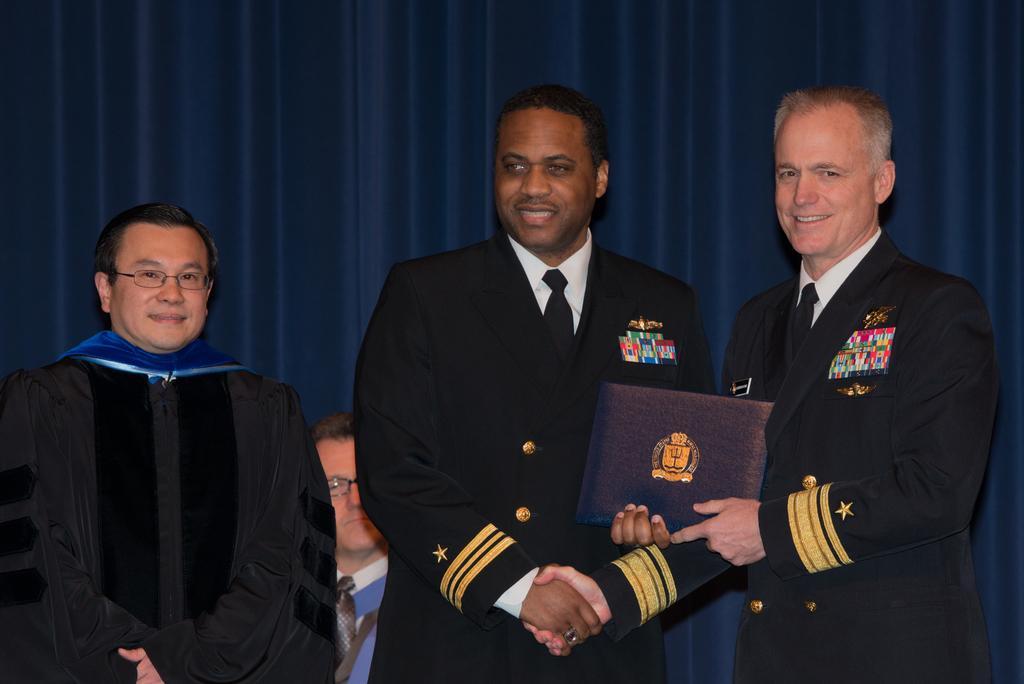Can you describe this image briefly? In this image we can see three persons standing. In the back there is another person. Two persons are wearing specs. And two other persons are holding something in the hand. In the background there is curtain. 